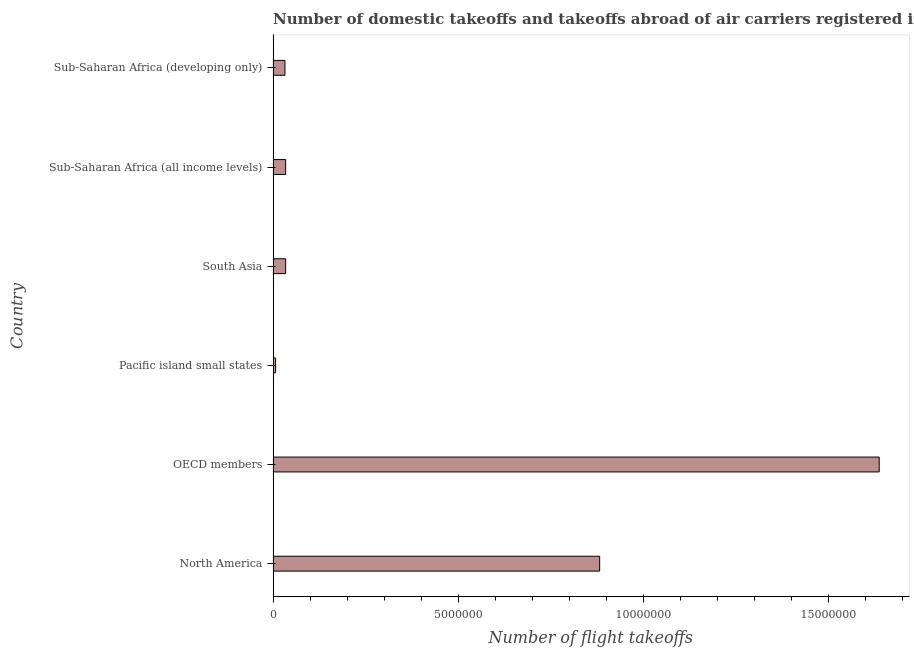Does the graph contain any zero values?
Provide a short and direct response. No. Does the graph contain grids?
Ensure brevity in your answer.  No. What is the title of the graph?
Offer a very short reply. Number of domestic takeoffs and takeoffs abroad of air carriers registered in countries. What is the label or title of the X-axis?
Keep it short and to the point. Number of flight takeoffs. What is the label or title of the Y-axis?
Your answer should be very brief. Country. What is the number of flight takeoffs in Sub-Saharan Africa (developing only)?
Provide a short and direct response. 3.20e+05. Across all countries, what is the maximum number of flight takeoffs?
Provide a short and direct response. 1.64e+07. Across all countries, what is the minimum number of flight takeoffs?
Make the answer very short. 6.71e+04. In which country was the number of flight takeoffs maximum?
Your answer should be compact. OECD members. In which country was the number of flight takeoffs minimum?
Give a very brief answer. Pacific island small states. What is the sum of the number of flight takeoffs?
Your response must be concise. 2.63e+07. What is the difference between the number of flight takeoffs in OECD members and Sub-Saharan Africa (all income levels)?
Give a very brief answer. 1.60e+07. What is the average number of flight takeoffs per country?
Keep it short and to the point. 4.38e+06. What is the median number of flight takeoffs?
Keep it short and to the point. 3.39e+05. In how many countries, is the number of flight takeoffs greater than 7000000 ?
Ensure brevity in your answer.  2. What is the ratio of the number of flight takeoffs in Pacific island small states to that in Sub-Saharan Africa (all income levels)?
Give a very brief answer. 0.2. Is the number of flight takeoffs in OECD members less than that in South Asia?
Give a very brief answer. No. Is the difference between the number of flight takeoffs in North America and OECD members greater than the difference between any two countries?
Give a very brief answer. No. What is the difference between the highest and the second highest number of flight takeoffs?
Ensure brevity in your answer.  7.55e+06. What is the difference between the highest and the lowest number of flight takeoffs?
Your answer should be very brief. 1.63e+07. In how many countries, is the number of flight takeoffs greater than the average number of flight takeoffs taken over all countries?
Make the answer very short. 2. How many bars are there?
Offer a terse response. 6. Are all the bars in the graph horizontal?
Your answer should be compact. Yes. How many countries are there in the graph?
Your answer should be compact. 6. What is the Number of flight takeoffs in North America?
Give a very brief answer. 8.83e+06. What is the Number of flight takeoffs of OECD members?
Your response must be concise. 1.64e+07. What is the Number of flight takeoffs of Pacific island small states?
Your response must be concise. 6.71e+04. What is the Number of flight takeoffs in South Asia?
Provide a short and direct response. 3.39e+05. What is the Number of flight takeoffs of Sub-Saharan Africa (all income levels)?
Your response must be concise. 3.39e+05. What is the Number of flight takeoffs in Sub-Saharan Africa (developing only)?
Provide a succinct answer. 3.20e+05. What is the difference between the Number of flight takeoffs in North America and OECD members?
Your response must be concise. -7.55e+06. What is the difference between the Number of flight takeoffs in North America and Pacific island small states?
Offer a terse response. 8.76e+06. What is the difference between the Number of flight takeoffs in North America and South Asia?
Ensure brevity in your answer.  8.49e+06. What is the difference between the Number of flight takeoffs in North America and Sub-Saharan Africa (all income levels)?
Offer a very short reply. 8.49e+06. What is the difference between the Number of flight takeoffs in North America and Sub-Saharan Africa (developing only)?
Offer a terse response. 8.51e+06. What is the difference between the Number of flight takeoffs in OECD members and Pacific island small states?
Offer a very short reply. 1.63e+07. What is the difference between the Number of flight takeoffs in OECD members and South Asia?
Your response must be concise. 1.60e+07. What is the difference between the Number of flight takeoffs in OECD members and Sub-Saharan Africa (all income levels)?
Your answer should be compact. 1.60e+07. What is the difference between the Number of flight takeoffs in OECD members and Sub-Saharan Africa (developing only)?
Your response must be concise. 1.61e+07. What is the difference between the Number of flight takeoffs in Pacific island small states and South Asia?
Offer a terse response. -2.72e+05. What is the difference between the Number of flight takeoffs in Pacific island small states and Sub-Saharan Africa (all income levels)?
Provide a short and direct response. -2.71e+05. What is the difference between the Number of flight takeoffs in Pacific island small states and Sub-Saharan Africa (developing only)?
Provide a short and direct response. -2.53e+05. What is the difference between the Number of flight takeoffs in South Asia and Sub-Saharan Africa (all income levels)?
Provide a succinct answer. 181. What is the difference between the Number of flight takeoffs in South Asia and Sub-Saharan Africa (developing only)?
Give a very brief answer. 1.88e+04. What is the difference between the Number of flight takeoffs in Sub-Saharan Africa (all income levels) and Sub-Saharan Africa (developing only)?
Your answer should be compact. 1.86e+04. What is the ratio of the Number of flight takeoffs in North America to that in OECD members?
Give a very brief answer. 0.54. What is the ratio of the Number of flight takeoffs in North America to that in Pacific island small states?
Give a very brief answer. 131.6. What is the ratio of the Number of flight takeoffs in North America to that in South Asia?
Ensure brevity in your answer.  26.06. What is the ratio of the Number of flight takeoffs in North America to that in Sub-Saharan Africa (all income levels)?
Offer a very short reply. 26.07. What is the ratio of the Number of flight takeoffs in North America to that in Sub-Saharan Africa (developing only)?
Your answer should be very brief. 27.59. What is the ratio of the Number of flight takeoffs in OECD members to that in Pacific island small states?
Your answer should be compact. 244.24. What is the ratio of the Number of flight takeoffs in OECD members to that in South Asia?
Your answer should be compact. 48.36. What is the ratio of the Number of flight takeoffs in OECD members to that in Sub-Saharan Africa (all income levels)?
Provide a succinct answer. 48.39. What is the ratio of the Number of flight takeoffs in OECD members to that in Sub-Saharan Africa (developing only)?
Provide a short and direct response. 51.21. What is the ratio of the Number of flight takeoffs in Pacific island small states to that in South Asia?
Provide a short and direct response. 0.2. What is the ratio of the Number of flight takeoffs in Pacific island small states to that in Sub-Saharan Africa (all income levels)?
Your answer should be very brief. 0.2. What is the ratio of the Number of flight takeoffs in Pacific island small states to that in Sub-Saharan Africa (developing only)?
Your answer should be compact. 0.21. What is the ratio of the Number of flight takeoffs in South Asia to that in Sub-Saharan Africa (developing only)?
Give a very brief answer. 1.06. What is the ratio of the Number of flight takeoffs in Sub-Saharan Africa (all income levels) to that in Sub-Saharan Africa (developing only)?
Ensure brevity in your answer.  1.06. 